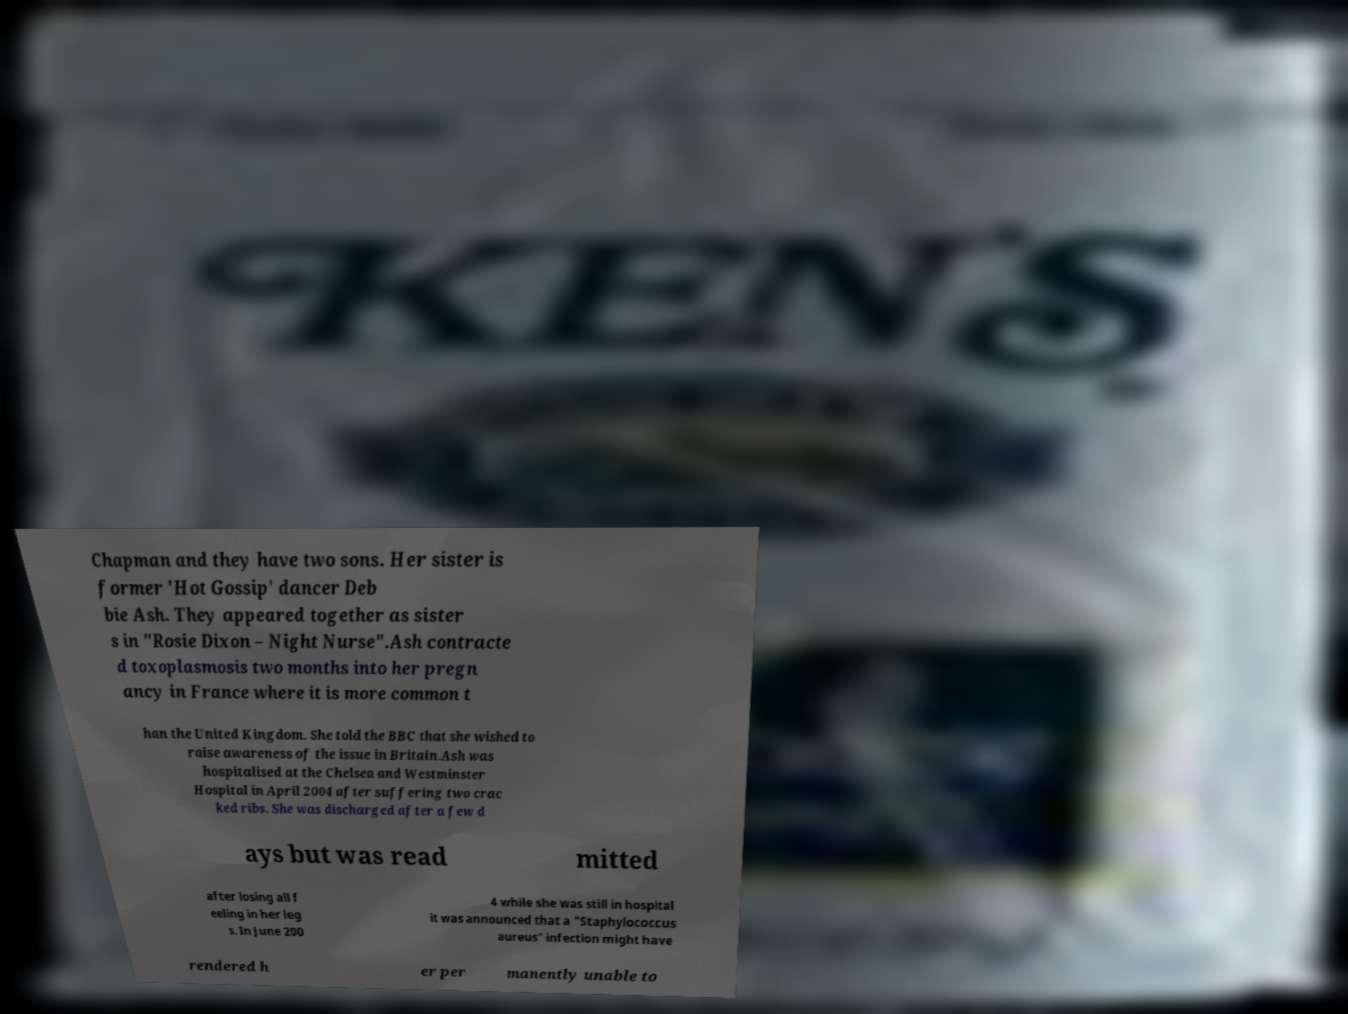Please identify and transcribe the text found in this image. Chapman and they have two sons. Her sister is former 'Hot Gossip' dancer Deb bie Ash. They appeared together as sister s in "Rosie Dixon – Night Nurse".Ash contracte d toxoplasmosis two months into her pregn ancy in France where it is more common t han the United Kingdom. She told the BBC that she wished to raise awareness of the issue in Britain.Ash was hospitalised at the Chelsea and Westminster Hospital in April 2004 after suffering two crac ked ribs. She was discharged after a few d ays but was read mitted after losing all f eeling in her leg s. In June 200 4 while she was still in hospital it was announced that a "Staphylococcus aureus" infection might have rendered h er per manently unable to 